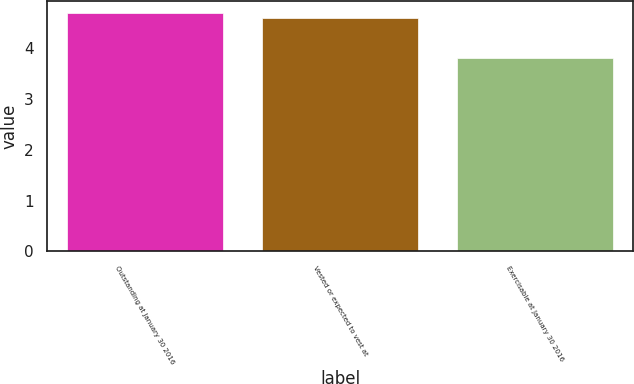Convert chart. <chart><loc_0><loc_0><loc_500><loc_500><bar_chart><fcel>Outstanding at January 30 2016<fcel>Vested or expected to vest at<fcel>Exercisable at January 30 2016<nl><fcel>4.7<fcel>4.6<fcel>3.8<nl></chart> 